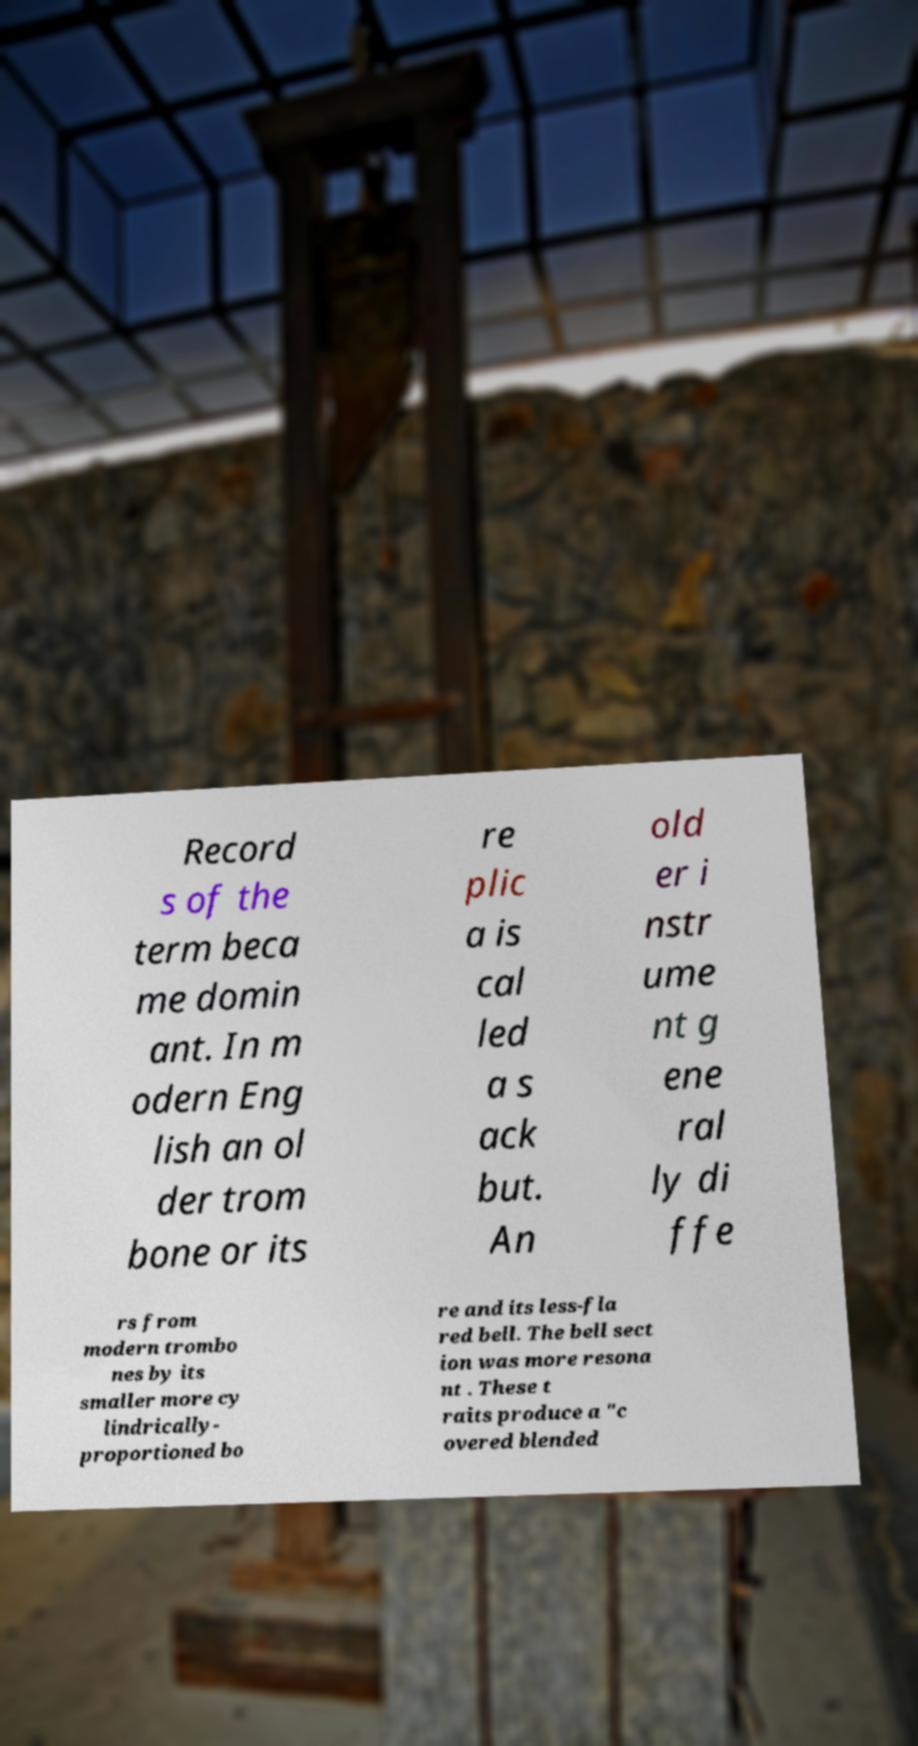For documentation purposes, I need the text within this image transcribed. Could you provide that? Record s of the term beca me domin ant. In m odern Eng lish an ol der trom bone or its re plic a is cal led a s ack but. An old er i nstr ume nt g ene ral ly di ffe rs from modern trombo nes by its smaller more cy lindrically- proportioned bo re and its less-fla red bell. The bell sect ion was more resona nt . These t raits produce a "c overed blended 